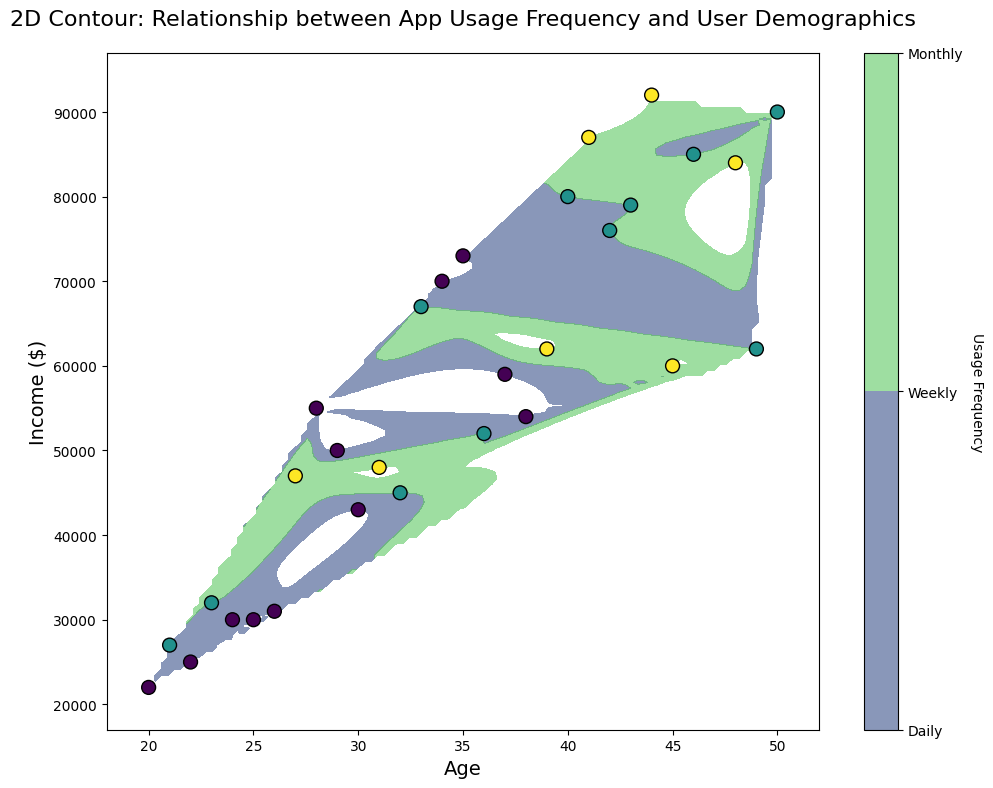what relationship can be observed between age and app usage frequency? By examining the contour plot, we see that younger users tend to use the app more frequently (with usage frequencies marked as "Daily"). As age increases, the app usage frequency appears to decrease, with more older users using the app on a weekly or monthly basis. The color gradient from dark green (daily) to light yellow (monthly) reflects this trend.
Answer: Younger users use the app more frequently Do higher-income users tend to use the app more or less frequently? Observing the figure, it becomes clear that users with higher incomes (above $60000) are more likely to use the app weekly or monthly. The lighter green to yellow colors in the higher-income range indicate less frequent usage compared to lower-income users who predominantly appear in darker green zones.
Answer: Higher-income users use the app less frequently What's the average age of daily app users? To determine this, focus on the darker green regions in the contour plot that indicate daily users. The age values within these regions span approximately from 20 to 35 years. Summing these values and dividing by the number of values (16 daily users) gives (20+22+23+24+25+26+27+28+29+30+31+32+33+34+35)/16 = 29 in average.
Answer: 29 years Do male users demonstrate higher app usage frequency than female users? By analyzing the scatter plot points with the color gradient, it’s noticeable that female users (represented by many points in the darker region) tend to use the app more frequently on a daily basis compared to male users who span a range of colors indicating varied frequencies.
Answer: Female users have higher usage frequency Is there any significant usage pattern among non-binary users? Observing the scatter points representing non-binary users, it appears that they primarily use the app daily or weekly as evidenced by the color and density of points within the darker green to intermediate green regions. Points corresponding to non-binary users are mostly clustered in these regions.
Answer: Non-binary users use the app daily or weekly What can you conclude about the app usage frequency for users aged between 30 and 40? By focusing on the age range of 30 to 40 in the contour plot, it appears that users in this age bracket exhibit varied usage frequencies. The regions depict a mix of intermediate green (weekly) and yellow (monthly) colors. This indicates that users in their 30s to early 40s use the app with medium to low frequency.
Answer: Medium to low frequency Which group, based on income, is most likely to use the app monthly? By scanning the entire contour plot, the higher-income users (above $60000) show a greater tendency to use the app monthly as indicated by the light yellow areas within the plot, compared to lower-income groups primarily in dark green regions.
Answer: Higher-income users Do younger males prefer daily usage compared to females? Comparing the scatter points for male and female users in the age range of 20-30, females in dark green zones suggest a higher preference for daily usage compared to males who are more distributed across weekly and monthly usages.
Answer: Females prefer daily usage more What's the income distribution for daily users? Observing the scatter points within dark green areas across the contour plot from left (lower) income to right (higher) income, the distribution seems to fall predominantly under the income range of $22,000 to $55,000 with a few scattered at higher incomes.
Answer: $22,000 to $55,000 mainly Does the usage frequency pattern change for users over the age of 40? The contour plot demonstrates a shift in color gradient toward lighter green and yellow as we move past the age of 40. This shift indicates that users over 40 are more likely to use the app on a weekly or monthly basis rather than daily.
Answer: Usage frequency decreases 